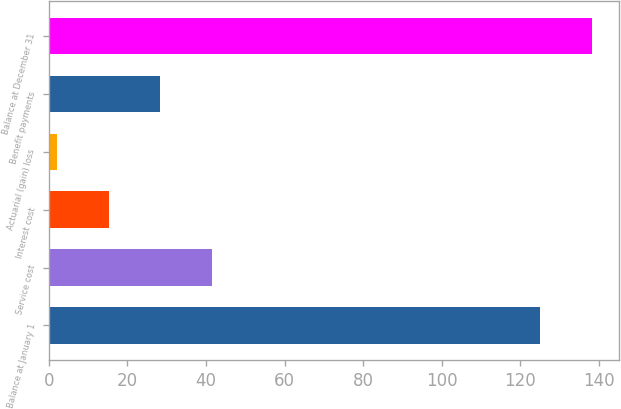Convert chart to OTSL. <chart><loc_0><loc_0><loc_500><loc_500><bar_chart><fcel>Balance at January 1<fcel>Service cost<fcel>Interest cost<fcel>Actuarial (gain) loss<fcel>Benefit payments<fcel>Balance at December 31<nl><fcel>125<fcel>41.6<fcel>15.2<fcel>2<fcel>28.4<fcel>138.2<nl></chart> 